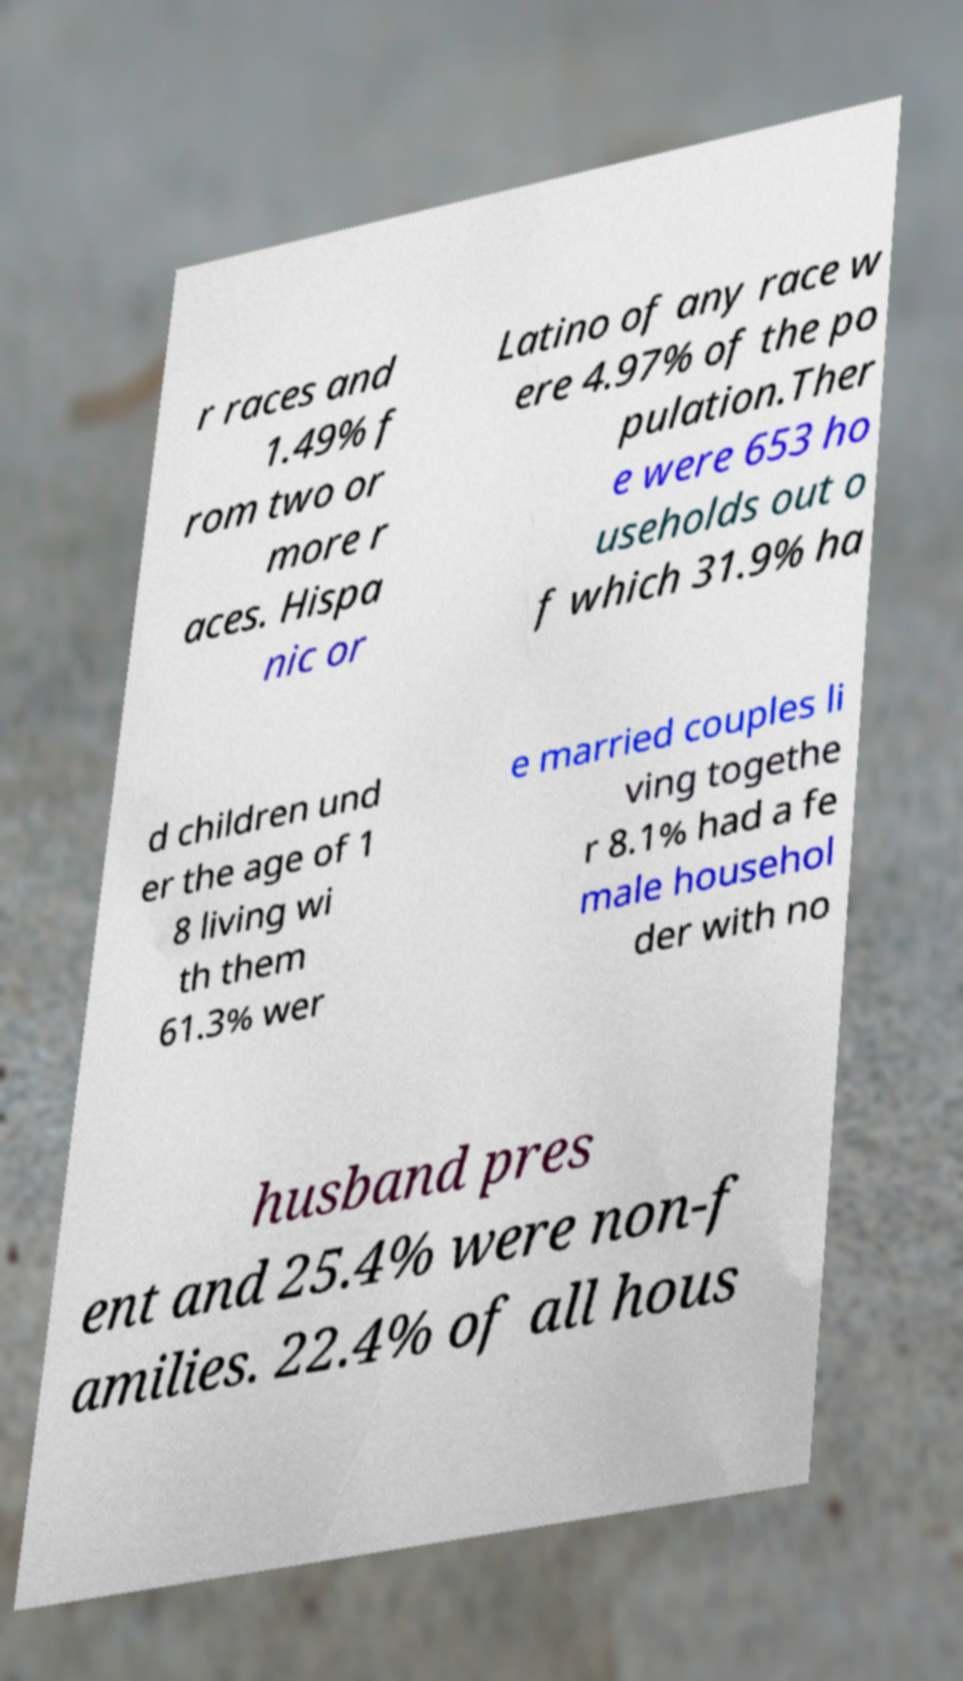Can you accurately transcribe the text from the provided image for me? r races and 1.49% f rom two or more r aces. Hispa nic or Latino of any race w ere 4.97% of the po pulation.Ther e were 653 ho useholds out o f which 31.9% ha d children und er the age of 1 8 living wi th them 61.3% wer e married couples li ving togethe r 8.1% had a fe male househol der with no husband pres ent and 25.4% were non-f amilies. 22.4% of all hous 